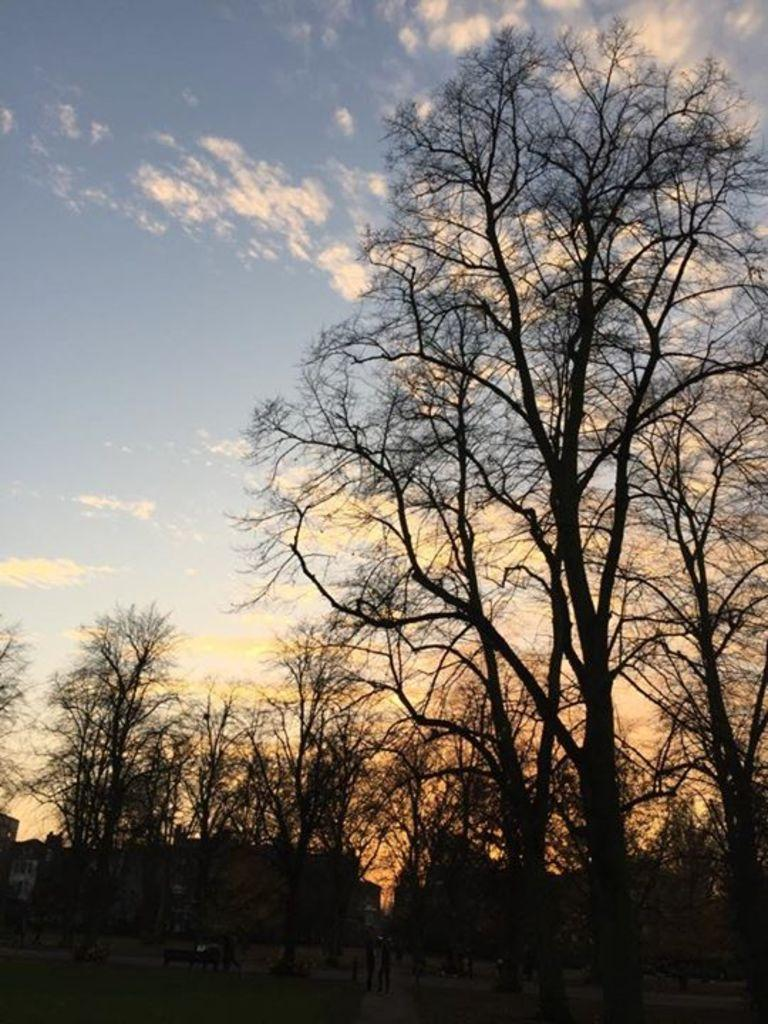What type of natural elements can be seen on the ground in the image? There are trees on the ground in the image. What type of man-made structures can be seen on the ground in the image? There are buildings on the ground in the image. What is the color of the sky in the background of the image? The sky is blue in the background of the image. What other atmospheric elements can be seen in the background of the image? There are clouds in the background of the image. What type of rhythm can be heard coming from the trees in the image? There is no sound or rhythm present in the image; it is a still image of trees and buildings. What type of yarn is being used to mark the territory in the image? There is no yarn or territory marking present in the image; it features trees and buildings. 